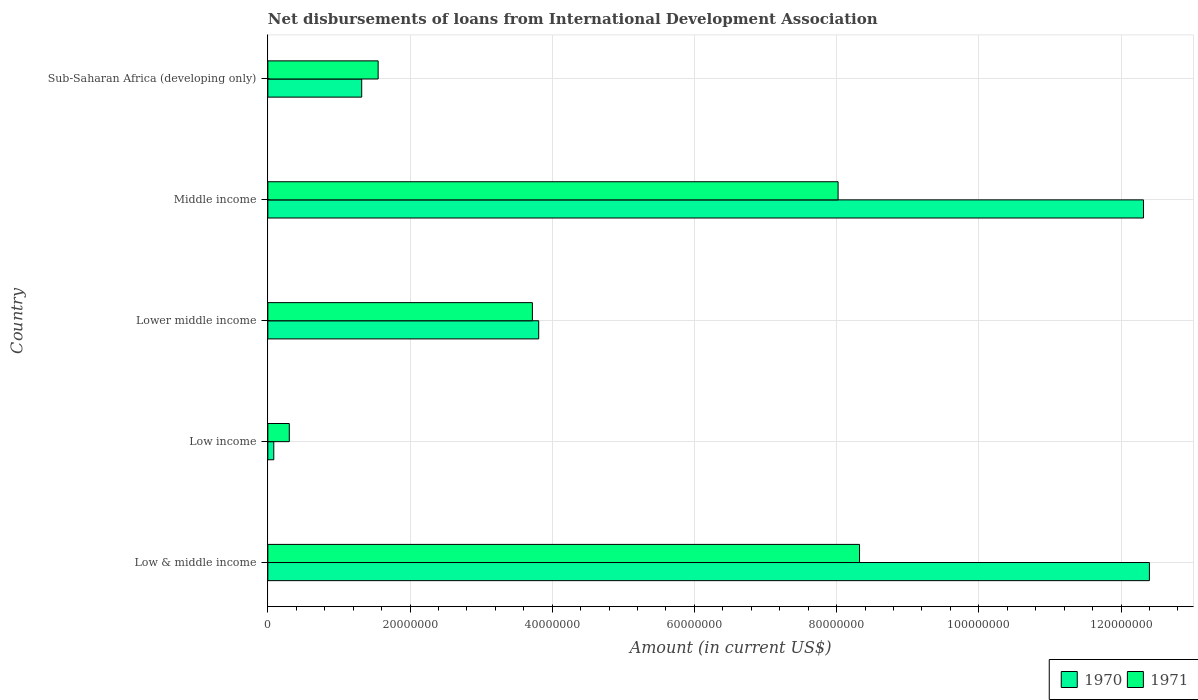Are the number of bars on each tick of the Y-axis equal?
Offer a very short reply. Yes. What is the label of the 2nd group of bars from the top?
Give a very brief answer. Middle income. What is the amount of loans disbursed in 1971 in Sub-Saharan Africa (developing only)?
Ensure brevity in your answer.  1.55e+07. Across all countries, what is the maximum amount of loans disbursed in 1970?
Offer a terse response. 1.24e+08. Across all countries, what is the minimum amount of loans disbursed in 1970?
Offer a very short reply. 8.35e+05. What is the total amount of loans disbursed in 1971 in the graph?
Offer a terse response. 2.19e+08. What is the difference between the amount of loans disbursed in 1971 in Low & middle income and that in Low income?
Your answer should be very brief. 8.02e+07. What is the difference between the amount of loans disbursed in 1971 in Lower middle income and the amount of loans disbursed in 1970 in Low & middle income?
Offer a very short reply. -8.68e+07. What is the average amount of loans disbursed in 1971 per country?
Make the answer very short. 4.38e+07. What is the difference between the amount of loans disbursed in 1970 and amount of loans disbursed in 1971 in Lower middle income?
Make the answer very short. 8.88e+05. What is the ratio of the amount of loans disbursed in 1970 in Low income to that in Middle income?
Make the answer very short. 0.01. What is the difference between the highest and the second highest amount of loans disbursed in 1971?
Keep it short and to the point. 3.02e+06. What is the difference between the highest and the lowest amount of loans disbursed in 1970?
Your response must be concise. 1.23e+08. Is the sum of the amount of loans disbursed in 1971 in Low & middle income and Lower middle income greater than the maximum amount of loans disbursed in 1970 across all countries?
Your response must be concise. No. Does the graph contain grids?
Provide a short and direct response. Yes. How are the legend labels stacked?
Offer a terse response. Horizontal. What is the title of the graph?
Offer a terse response. Net disbursements of loans from International Development Association. Does "1971" appear as one of the legend labels in the graph?
Make the answer very short. Yes. What is the Amount (in current US$) in 1970 in Low & middle income?
Provide a short and direct response. 1.24e+08. What is the Amount (in current US$) of 1971 in Low & middle income?
Your answer should be compact. 8.32e+07. What is the Amount (in current US$) of 1970 in Low income?
Make the answer very short. 8.35e+05. What is the Amount (in current US$) of 1971 in Low income?
Make the answer very short. 3.02e+06. What is the Amount (in current US$) in 1970 in Lower middle income?
Keep it short and to the point. 3.81e+07. What is the Amount (in current US$) in 1971 in Lower middle income?
Offer a terse response. 3.72e+07. What is the Amount (in current US$) of 1970 in Middle income?
Provide a succinct answer. 1.23e+08. What is the Amount (in current US$) in 1971 in Middle income?
Keep it short and to the point. 8.02e+07. What is the Amount (in current US$) in 1970 in Sub-Saharan Africa (developing only)?
Provide a succinct answer. 1.32e+07. What is the Amount (in current US$) of 1971 in Sub-Saharan Africa (developing only)?
Your response must be concise. 1.55e+07. Across all countries, what is the maximum Amount (in current US$) in 1970?
Ensure brevity in your answer.  1.24e+08. Across all countries, what is the maximum Amount (in current US$) of 1971?
Offer a terse response. 8.32e+07. Across all countries, what is the minimum Amount (in current US$) of 1970?
Your answer should be compact. 8.35e+05. Across all countries, what is the minimum Amount (in current US$) in 1971?
Keep it short and to the point. 3.02e+06. What is the total Amount (in current US$) in 1970 in the graph?
Your answer should be compact. 2.99e+08. What is the total Amount (in current US$) in 1971 in the graph?
Keep it short and to the point. 2.19e+08. What is the difference between the Amount (in current US$) of 1970 in Low & middle income and that in Low income?
Provide a short and direct response. 1.23e+08. What is the difference between the Amount (in current US$) in 1971 in Low & middle income and that in Low income?
Provide a succinct answer. 8.02e+07. What is the difference between the Amount (in current US$) in 1970 in Low & middle income and that in Lower middle income?
Provide a succinct answer. 8.59e+07. What is the difference between the Amount (in current US$) in 1971 in Low & middle income and that in Lower middle income?
Give a very brief answer. 4.60e+07. What is the difference between the Amount (in current US$) of 1970 in Low & middle income and that in Middle income?
Offer a terse response. 8.35e+05. What is the difference between the Amount (in current US$) of 1971 in Low & middle income and that in Middle income?
Offer a very short reply. 3.02e+06. What is the difference between the Amount (in current US$) in 1970 in Low & middle income and that in Sub-Saharan Africa (developing only)?
Provide a short and direct response. 1.11e+08. What is the difference between the Amount (in current US$) of 1971 in Low & middle income and that in Sub-Saharan Africa (developing only)?
Your response must be concise. 6.77e+07. What is the difference between the Amount (in current US$) of 1970 in Low income and that in Lower middle income?
Provide a short and direct response. -3.73e+07. What is the difference between the Amount (in current US$) in 1971 in Low income and that in Lower middle income?
Provide a short and direct response. -3.42e+07. What is the difference between the Amount (in current US$) in 1970 in Low income and that in Middle income?
Your response must be concise. -1.22e+08. What is the difference between the Amount (in current US$) in 1971 in Low income and that in Middle income?
Make the answer very short. -7.72e+07. What is the difference between the Amount (in current US$) of 1970 in Low income and that in Sub-Saharan Africa (developing only)?
Provide a short and direct response. -1.24e+07. What is the difference between the Amount (in current US$) of 1971 in Low income and that in Sub-Saharan Africa (developing only)?
Provide a succinct answer. -1.25e+07. What is the difference between the Amount (in current US$) in 1970 in Lower middle income and that in Middle income?
Keep it short and to the point. -8.51e+07. What is the difference between the Amount (in current US$) of 1971 in Lower middle income and that in Middle income?
Ensure brevity in your answer.  -4.30e+07. What is the difference between the Amount (in current US$) in 1970 in Lower middle income and that in Sub-Saharan Africa (developing only)?
Keep it short and to the point. 2.49e+07. What is the difference between the Amount (in current US$) in 1971 in Lower middle income and that in Sub-Saharan Africa (developing only)?
Provide a short and direct response. 2.17e+07. What is the difference between the Amount (in current US$) of 1970 in Middle income and that in Sub-Saharan Africa (developing only)?
Keep it short and to the point. 1.10e+08. What is the difference between the Amount (in current US$) in 1971 in Middle income and that in Sub-Saharan Africa (developing only)?
Provide a short and direct response. 6.47e+07. What is the difference between the Amount (in current US$) of 1970 in Low & middle income and the Amount (in current US$) of 1971 in Low income?
Provide a short and direct response. 1.21e+08. What is the difference between the Amount (in current US$) of 1970 in Low & middle income and the Amount (in current US$) of 1971 in Lower middle income?
Provide a succinct answer. 8.68e+07. What is the difference between the Amount (in current US$) of 1970 in Low & middle income and the Amount (in current US$) of 1971 in Middle income?
Your answer should be very brief. 4.38e+07. What is the difference between the Amount (in current US$) in 1970 in Low & middle income and the Amount (in current US$) in 1971 in Sub-Saharan Africa (developing only)?
Give a very brief answer. 1.08e+08. What is the difference between the Amount (in current US$) in 1970 in Low income and the Amount (in current US$) in 1971 in Lower middle income?
Provide a succinct answer. -3.64e+07. What is the difference between the Amount (in current US$) of 1970 in Low income and the Amount (in current US$) of 1971 in Middle income?
Ensure brevity in your answer.  -7.94e+07. What is the difference between the Amount (in current US$) of 1970 in Low income and the Amount (in current US$) of 1971 in Sub-Saharan Africa (developing only)?
Offer a terse response. -1.47e+07. What is the difference between the Amount (in current US$) in 1970 in Lower middle income and the Amount (in current US$) in 1971 in Middle income?
Ensure brevity in your answer.  -4.21e+07. What is the difference between the Amount (in current US$) in 1970 in Lower middle income and the Amount (in current US$) in 1971 in Sub-Saharan Africa (developing only)?
Provide a succinct answer. 2.26e+07. What is the difference between the Amount (in current US$) of 1970 in Middle income and the Amount (in current US$) of 1971 in Sub-Saharan Africa (developing only)?
Keep it short and to the point. 1.08e+08. What is the average Amount (in current US$) in 1970 per country?
Your answer should be compact. 5.99e+07. What is the average Amount (in current US$) of 1971 per country?
Your answer should be very brief. 4.38e+07. What is the difference between the Amount (in current US$) in 1970 and Amount (in current US$) in 1971 in Low & middle income?
Your answer should be very brief. 4.08e+07. What is the difference between the Amount (in current US$) of 1970 and Amount (in current US$) of 1971 in Low income?
Offer a very short reply. -2.18e+06. What is the difference between the Amount (in current US$) in 1970 and Amount (in current US$) in 1971 in Lower middle income?
Provide a short and direct response. 8.88e+05. What is the difference between the Amount (in current US$) of 1970 and Amount (in current US$) of 1971 in Middle income?
Your answer should be very brief. 4.30e+07. What is the difference between the Amount (in current US$) in 1970 and Amount (in current US$) in 1971 in Sub-Saharan Africa (developing only)?
Keep it short and to the point. -2.31e+06. What is the ratio of the Amount (in current US$) of 1970 in Low & middle income to that in Low income?
Provide a succinct answer. 148.5. What is the ratio of the Amount (in current US$) of 1971 in Low & middle income to that in Low income?
Provide a short and direct response. 27.59. What is the ratio of the Amount (in current US$) of 1970 in Low & middle income to that in Lower middle income?
Your response must be concise. 3.25. What is the ratio of the Amount (in current US$) of 1971 in Low & middle income to that in Lower middle income?
Your response must be concise. 2.24. What is the ratio of the Amount (in current US$) in 1970 in Low & middle income to that in Middle income?
Offer a very short reply. 1.01. What is the ratio of the Amount (in current US$) in 1971 in Low & middle income to that in Middle income?
Make the answer very short. 1.04. What is the ratio of the Amount (in current US$) in 1970 in Low & middle income to that in Sub-Saharan Africa (developing only)?
Keep it short and to the point. 9.39. What is the ratio of the Amount (in current US$) of 1971 in Low & middle income to that in Sub-Saharan Africa (developing only)?
Make the answer very short. 5.36. What is the ratio of the Amount (in current US$) in 1970 in Low income to that in Lower middle income?
Your response must be concise. 0.02. What is the ratio of the Amount (in current US$) of 1971 in Low income to that in Lower middle income?
Offer a terse response. 0.08. What is the ratio of the Amount (in current US$) in 1970 in Low income to that in Middle income?
Your answer should be very brief. 0.01. What is the ratio of the Amount (in current US$) in 1971 in Low income to that in Middle income?
Your answer should be compact. 0.04. What is the ratio of the Amount (in current US$) in 1970 in Low income to that in Sub-Saharan Africa (developing only)?
Provide a short and direct response. 0.06. What is the ratio of the Amount (in current US$) in 1971 in Low income to that in Sub-Saharan Africa (developing only)?
Give a very brief answer. 0.19. What is the ratio of the Amount (in current US$) in 1970 in Lower middle income to that in Middle income?
Make the answer very short. 0.31. What is the ratio of the Amount (in current US$) in 1971 in Lower middle income to that in Middle income?
Give a very brief answer. 0.46. What is the ratio of the Amount (in current US$) of 1970 in Lower middle income to that in Sub-Saharan Africa (developing only)?
Offer a terse response. 2.89. What is the ratio of the Amount (in current US$) in 1971 in Lower middle income to that in Sub-Saharan Africa (developing only)?
Your answer should be very brief. 2.4. What is the ratio of the Amount (in current US$) in 1970 in Middle income to that in Sub-Saharan Africa (developing only)?
Make the answer very short. 9.33. What is the ratio of the Amount (in current US$) in 1971 in Middle income to that in Sub-Saharan Africa (developing only)?
Provide a succinct answer. 5.17. What is the difference between the highest and the second highest Amount (in current US$) in 1970?
Keep it short and to the point. 8.35e+05. What is the difference between the highest and the second highest Amount (in current US$) of 1971?
Offer a very short reply. 3.02e+06. What is the difference between the highest and the lowest Amount (in current US$) of 1970?
Offer a very short reply. 1.23e+08. What is the difference between the highest and the lowest Amount (in current US$) of 1971?
Give a very brief answer. 8.02e+07. 